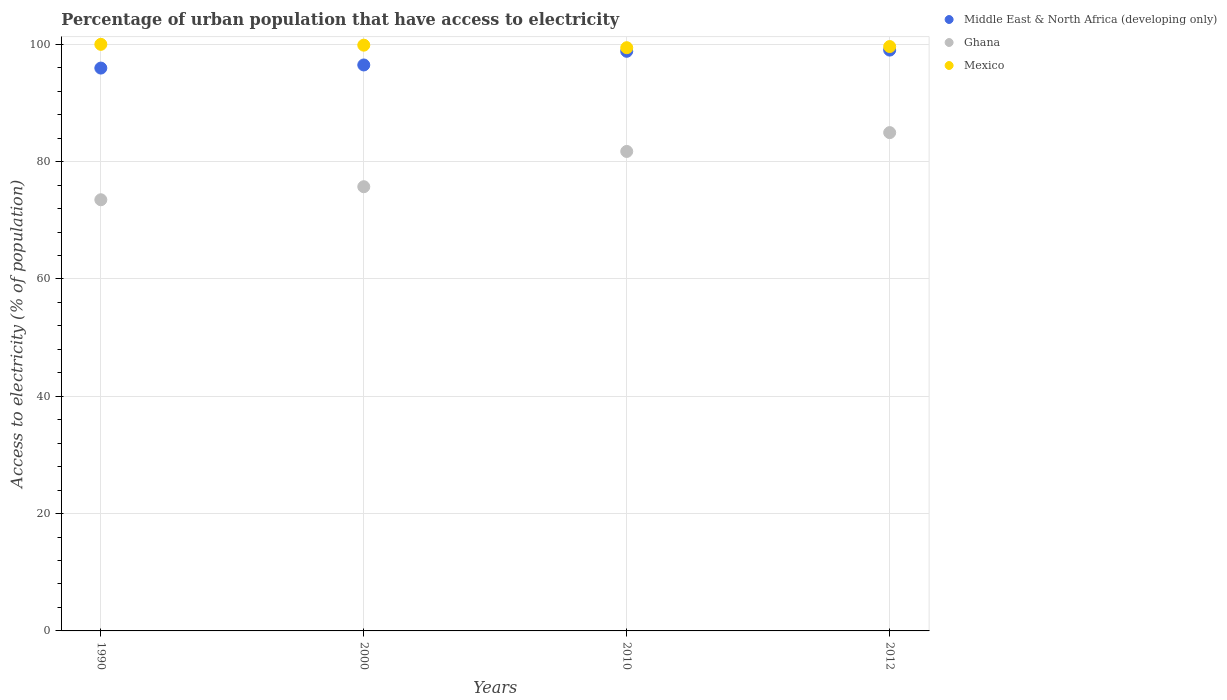How many different coloured dotlines are there?
Your response must be concise. 3. What is the percentage of urban population that have access to electricity in Mexico in 2010?
Ensure brevity in your answer.  99.43. Across all years, what is the maximum percentage of urban population that have access to electricity in Middle East & North Africa (developing only)?
Offer a terse response. 99.02. Across all years, what is the minimum percentage of urban population that have access to electricity in Mexico?
Give a very brief answer. 99.43. In which year was the percentage of urban population that have access to electricity in Middle East & North Africa (developing only) maximum?
Provide a succinct answer. 2012. In which year was the percentage of urban population that have access to electricity in Ghana minimum?
Ensure brevity in your answer.  1990. What is the total percentage of urban population that have access to electricity in Middle East & North Africa (developing only) in the graph?
Ensure brevity in your answer.  390.28. What is the difference between the percentage of urban population that have access to electricity in Middle East & North Africa (developing only) in 2010 and that in 2012?
Ensure brevity in your answer.  -0.2. What is the difference between the percentage of urban population that have access to electricity in Mexico in 2000 and the percentage of urban population that have access to electricity in Ghana in 2012?
Your answer should be compact. 14.91. What is the average percentage of urban population that have access to electricity in Middle East & North Africa (developing only) per year?
Offer a very short reply. 97.57. In the year 1990, what is the difference between the percentage of urban population that have access to electricity in Mexico and percentage of urban population that have access to electricity in Middle East & North Africa (developing only)?
Make the answer very short. 4.05. In how many years, is the percentage of urban population that have access to electricity in Middle East & North Africa (developing only) greater than 96 %?
Provide a succinct answer. 3. What is the ratio of the percentage of urban population that have access to electricity in Middle East & North Africa (developing only) in 1990 to that in 2012?
Keep it short and to the point. 0.97. Is the difference between the percentage of urban population that have access to electricity in Mexico in 2000 and 2012 greater than the difference between the percentage of urban population that have access to electricity in Middle East & North Africa (developing only) in 2000 and 2012?
Provide a short and direct response. Yes. What is the difference between the highest and the second highest percentage of urban population that have access to electricity in Ghana?
Provide a succinct answer. 3.21. What is the difference between the highest and the lowest percentage of urban population that have access to electricity in Middle East & North Africa (developing only)?
Offer a very short reply. 3.07. In how many years, is the percentage of urban population that have access to electricity in Mexico greater than the average percentage of urban population that have access to electricity in Mexico taken over all years?
Offer a very short reply. 2. Does the percentage of urban population that have access to electricity in Middle East & North Africa (developing only) monotonically increase over the years?
Your response must be concise. Yes. Does the graph contain any zero values?
Offer a very short reply. No. How many legend labels are there?
Your answer should be very brief. 3. How are the legend labels stacked?
Provide a short and direct response. Vertical. What is the title of the graph?
Make the answer very short. Percentage of urban population that have access to electricity. Does "Syrian Arab Republic" appear as one of the legend labels in the graph?
Give a very brief answer. No. What is the label or title of the X-axis?
Your response must be concise. Years. What is the label or title of the Y-axis?
Ensure brevity in your answer.  Access to electricity (% of population). What is the Access to electricity (% of population) in Middle East & North Africa (developing only) in 1990?
Your answer should be compact. 95.95. What is the Access to electricity (% of population) of Ghana in 1990?
Offer a very short reply. 73.51. What is the Access to electricity (% of population) in Middle East & North Africa (developing only) in 2000?
Offer a terse response. 96.48. What is the Access to electricity (% of population) in Ghana in 2000?
Your answer should be compact. 75.73. What is the Access to electricity (% of population) in Mexico in 2000?
Offer a very short reply. 99.86. What is the Access to electricity (% of population) in Middle East & North Africa (developing only) in 2010?
Offer a very short reply. 98.82. What is the Access to electricity (% of population) in Ghana in 2010?
Give a very brief answer. 81.74. What is the Access to electricity (% of population) in Mexico in 2010?
Your answer should be compact. 99.43. What is the Access to electricity (% of population) of Middle East & North Africa (developing only) in 2012?
Make the answer very short. 99.02. What is the Access to electricity (% of population) in Ghana in 2012?
Your answer should be very brief. 84.95. What is the Access to electricity (% of population) of Mexico in 2012?
Offer a terse response. 99.62. Across all years, what is the maximum Access to electricity (% of population) of Middle East & North Africa (developing only)?
Make the answer very short. 99.02. Across all years, what is the maximum Access to electricity (% of population) in Ghana?
Ensure brevity in your answer.  84.95. Across all years, what is the maximum Access to electricity (% of population) in Mexico?
Offer a very short reply. 100. Across all years, what is the minimum Access to electricity (% of population) of Middle East & North Africa (developing only)?
Provide a succinct answer. 95.95. Across all years, what is the minimum Access to electricity (% of population) of Ghana?
Make the answer very short. 73.51. Across all years, what is the minimum Access to electricity (% of population) of Mexico?
Ensure brevity in your answer.  99.43. What is the total Access to electricity (% of population) of Middle East & North Africa (developing only) in the graph?
Give a very brief answer. 390.28. What is the total Access to electricity (% of population) of Ghana in the graph?
Offer a very short reply. 315.93. What is the total Access to electricity (% of population) in Mexico in the graph?
Your answer should be compact. 398.91. What is the difference between the Access to electricity (% of population) of Middle East & North Africa (developing only) in 1990 and that in 2000?
Give a very brief answer. -0.53. What is the difference between the Access to electricity (% of population) of Ghana in 1990 and that in 2000?
Your response must be concise. -2.22. What is the difference between the Access to electricity (% of population) in Mexico in 1990 and that in 2000?
Your answer should be very brief. 0.14. What is the difference between the Access to electricity (% of population) of Middle East & North Africa (developing only) in 1990 and that in 2010?
Keep it short and to the point. -2.86. What is the difference between the Access to electricity (% of population) of Ghana in 1990 and that in 2010?
Your answer should be very brief. -8.24. What is the difference between the Access to electricity (% of population) in Mexico in 1990 and that in 2010?
Provide a succinct answer. 0.57. What is the difference between the Access to electricity (% of population) in Middle East & North Africa (developing only) in 1990 and that in 2012?
Offer a terse response. -3.07. What is the difference between the Access to electricity (% of population) of Ghana in 1990 and that in 2012?
Your response must be concise. -11.45. What is the difference between the Access to electricity (% of population) of Mexico in 1990 and that in 2012?
Offer a very short reply. 0.38. What is the difference between the Access to electricity (% of population) in Middle East & North Africa (developing only) in 2000 and that in 2010?
Your response must be concise. -2.33. What is the difference between the Access to electricity (% of population) in Ghana in 2000 and that in 2010?
Your response must be concise. -6.01. What is the difference between the Access to electricity (% of population) in Mexico in 2000 and that in 2010?
Your answer should be very brief. 0.43. What is the difference between the Access to electricity (% of population) of Middle East & North Africa (developing only) in 2000 and that in 2012?
Ensure brevity in your answer.  -2.54. What is the difference between the Access to electricity (% of population) in Ghana in 2000 and that in 2012?
Give a very brief answer. -9.22. What is the difference between the Access to electricity (% of population) of Mexico in 2000 and that in 2012?
Make the answer very short. 0.24. What is the difference between the Access to electricity (% of population) in Middle East & North Africa (developing only) in 2010 and that in 2012?
Make the answer very short. -0.2. What is the difference between the Access to electricity (% of population) of Ghana in 2010 and that in 2012?
Ensure brevity in your answer.  -3.21. What is the difference between the Access to electricity (% of population) of Mexico in 2010 and that in 2012?
Provide a short and direct response. -0.2. What is the difference between the Access to electricity (% of population) in Middle East & North Africa (developing only) in 1990 and the Access to electricity (% of population) in Ghana in 2000?
Keep it short and to the point. 20.22. What is the difference between the Access to electricity (% of population) of Middle East & North Africa (developing only) in 1990 and the Access to electricity (% of population) of Mexico in 2000?
Make the answer very short. -3.91. What is the difference between the Access to electricity (% of population) of Ghana in 1990 and the Access to electricity (% of population) of Mexico in 2000?
Give a very brief answer. -26.35. What is the difference between the Access to electricity (% of population) in Middle East & North Africa (developing only) in 1990 and the Access to electricity (% of population) in Ghana in 2010?
Make the answer very short. 14.21. What is the difference between the Access to electricity (% of population) of Middle East & North Africa (developing only) in 1990 and the Access to electricity (% of population) of Mexico in 2010?
Make the answer very short. -3.47. What is the difference between the Access to electricity (% of population) of Ghana in 1990 and the Access to electricity (% of population) of Mexico in 2010?
Ensure brevity in your answer.  -25.92. What is the difference between the Access to electricity (% of population) in Middle East & North Africa (developing only) in 1990 and the Access to electricity (% of population) in Ghana in 2012?
Give a very brief answer. 11. What is the difference between the Access to electricity (% of population) in Middle East & North Africa (developing only) in 1990 and the Access to electricity (% of population) in Mexico in 2012?
Give a very brief answer. -3.67. What is the difference between the Access to electricity (% of population) in Ghana in 1990 and the Access to electricity (% of population) in Mexico in 2012?
Offer a terse response. -26.12. What is the difference between the Access to electricity (% of population) of Middle East & North Africa (developing only) in 2000 and the Access to electricity (% of population) of Ghana in 2010?
Your response must be concise. 14.74. What is the difference between the Access to electricity (% of population) in Middle East & North Africa (developing only) in 2000 and the Access to electricity (% of population) in Mexico in 2010?
Offer a terse response. -2.94. What is the difference between the Access to electricity (% of population) of Ghana in 2000 and the Access to electricity (% of population) of Mexico in 2010?
Keep it short and to the point. -23.7. What is the difference between the Access to electricity (% of population) in Middle East & North Africa (developing only) in 2000 and the Access to electricity (% of population) in Ghana in 2012?
Give a very brief answer. 11.53. What is the difference between the Access to electricity (% of population) in Middle East & North Africa (developing only) in 2000 and the Access to electricity (% of population) in Mexico in 2012?
Offer a terse response. -3.14. What is the difference between the Access to electricity (% of population) in Ghana in 2000 and the Access to electricity (% of population) in Mexico in 2012?
Your answer should be very brief. -23.89. What is the difference between the Access to electricity (% of population) in Middle East & North Africa (developing only) in 2010 and the Access to electricity (% of population) in Ghana in 2012?
Your answer should be compact. 13.86. What is the difference between the Access to electricity (% of population) in Middle East & North Africa (developing only) in 2010 and the Access to electricity (% of population) in Mexico in 2012?
Your response must be concise. -0.81. What is the difference between the Access to electricity (% of population) of Ghana in 2010 and the Access to electricity (% of population) of Mexico in 2012?
Offer a terse response. -17.88. What is the average Access to electricity (% of population) in Middle East & North Africa (developing only) per year?
Provide a succinct answer. 97.57. What is the average Access to electricity (% of population) of Ghana per year?
Provide a short and direct response. 78.98. What is the average Access to electricity (% of population) in Mexico per year?
Offer a very short reply. 99.73. In the year 1990, what is the difference between the Access to electricity (% of population) of Middle East & North Africa (developing only) and Access to electricity (% of population) of Ghana?
Your answer should be compact. 22.45. In the year 1990, what is the difference between the Access to electricity (% of population) in Middle East & North Africa (developing only) and Access to electricity (% of population) in Mexico?
Make the answer very short. -4.05. In the year 1990, what is the difference between the Access to electricity (% of population) of Ghana and Access to electricity (% of population) of Mexico?
Your response must be concise. -26.49. In the year 2000, what is the difference between the Access to electricity (% of population) in Middle East & North Africa (developing only) and Access to electricity (% of population) in Ghana?
Offer a very short reply. 20.75. In the year 2000, what is the difference between the Access to electricity (% of population) in Middle East & North Africa (developing only) and Access to electricity (% of population) in Mexico?
Your answer should be very brief. -3.38. In the year 2000, what is the difference between the Access to electricity (% of population) of Ghana and Access to electricity (% of population) of Mexico?
Offer a very short reply. -24.13. In the year 2010, what is the difference between the Access to electricity (% of population) in Middle East & North Africa (developing only) and Access to electricity (% of population) in Ghana?
Your response must be concise. 17.07. In the year 2010, what is the difference between the Access to electricity (% of population) in Middle East & North Africa (developing only) and Access to electricity (% of population) in Mexico?
Ensure brevity in your answer.  -0.61. In the year 2010, what is the difference between the Access to electricity (% of population) of Ghana and Access to electricity (% of population) of Mexico?
Keep it short and to the point. -17.69. In the year 2012, what is the difference between the Access to electricity (% of population) of Middle East & North Africa (developing only) and Access to electricity (% of population) of Ghana?
Give a very brief answer. 14.07. In the year 2012, what is the difference between the Access to electricity (% of population) of Middle East & North Africa (developing only) and Access to electricity (% of population) of Mexico?
Keep it short and to the point. -0.6. In the year 2012, what is the difference between the Access to electricity (% of population) in Ghana and Access to electricity (% of population) in Mexico?
Your answer should be compact. -14.67. What is the ratio of the Access to electricity (% of population) of Middle East & North Africa (developing only) in 1990 to that in 2000?
Your response must be concise. 0.99. What is the ratio of the Access to electricity (% of population) in Ghana in 1990 to that in 2000?
Keep it short and to the point. 0.97. What is the ratio of the Access to electricity (% of population) of Mexico in 1990 to that in 2000?
Provide a succinct answer. 1. What is the ratio of the Access to electricity (% of population) of Ghana in 1990 to that in 2010?
Provide a short and direct response. 0.9. What is the ratio of the Access to electricity (% of population) of Middle East & North Africa (developing only) in 1990 to that in 2012?
Provide a succinct answer. 0.97. What is the ratio of the Access to electricity (% of population) of Ghana in 1990 to that in 2012?
Provide a short and direct response. 0.87. What is the ratio of the Access to electricity (% of population) in Mexico in 1990 to that in 2012?
Give a very brief answer. 1. What is the ratio of the Access to electricity (% of population) of Middle East & North Africa (developing only) in 2000 to that in 2010?
Give a very brief answer. 0.98. What is the ratio of the Access to electricity (% of population) in Ghana in 2000 to that in 2010?
Provide a short and direct response. 0.93. What is the ratio of the Access to electricity (% of population) in Middle East & North Africa (developing only) in 2000 to that in 2012?
Your answer should be very brief. 0.97. What is the ratio of the Access to electricity (% of population) in Ghana in 2000 to that in 2012?
Offer a very short reply. 0.89. What is the ratio of the Access to electricity (% of population) in Mexico in 2000 to that in 2012?
Your answer should be very brief. 1. What is the ratio of the Access to electricity (% of population) in Middle East & North Africa (developing only) in 2010 to that in 2012?
Make the answer very short. 1. What is the ratio of the Access to electricity (% of population) in Ghana in 2010 to that in 2012?
Provide a short and direct response. 0.96. What is the ratio of the Access to electricity (% of population) in Mexico in 2010 to that in 2012?
Provide a succinct answer. 1. What is the difference between the highest and the second highest Access to electricity (% of population) in Middle East & North Africa (developing only)?
Provide a short and direct response. 0.2. What is the difference between the highest and the second highest Access to electricity (% of population) of Ghana?
Make the answer very short. 3.21. What is the difference between the highest and the second highest Access to electricity (% of population) of Mexico?
Offer a very short reply. 0.14. What is the difference between the highest and the lowest Access to electricity (% of population) in Middle East & North Africa (developing only)?
Ensure brevity in your answer.  3.07. What is the difference between the highest and the lowest Access to electricity (% of population) of Ghana?
Offer a very short reply. 11.45. What is the difference between the highest and the lowest Access to electricity (% of population) in Mexico?
Keep it short and to the point. 0.57. 